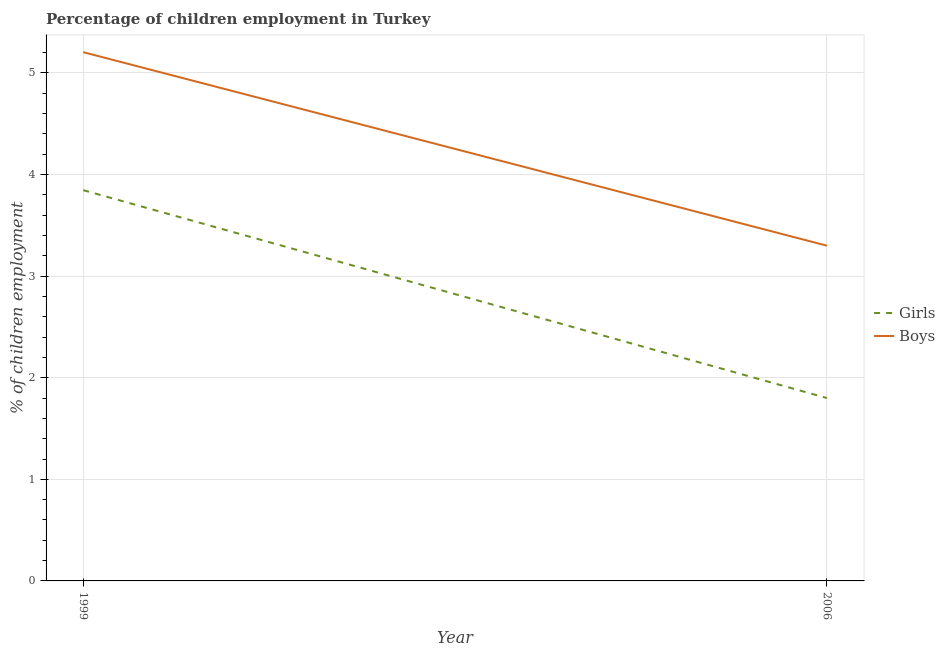How many different coloured lines are there?
Provide a succinct answer. 2. Does the line corresponding to percentage of employed boys intersect with the line corresponding to percentage of employed girls?
Provide a short and direct response. No. Is the number of lines equal to the number of legend labels?
Offer a very short reply. Yes. What is the percentage of employed boys in 1999?
Provide a succinct answer. 5.2. Across all years, what is the maximum percentage of employed boys?
Provide a succinct answer. 5.2. In which year was the percentage of employed girls minimum?
Provide a short and direct response. 2006. What is the total percentage of employed boys in the graph?
Keep it short and to the point. 8.5. What is the difference between the percentage of employed girls in 1999 and that in 2006?
Your response must be concise. 2.05. What is the difference between the percentage of employed girls in 2006 and the percentage of employed boys in 1999?
Your answer should be very brief. -3.4. What is the average percentage of employed girls per year?
Your answer should be very brief. 2.82. In the year 2006, what is the difference between the percentage of employed boys and percentage of employed girls?
Provide a succinct answer. 1.5. In how many years, is the percentage of employed boys greater than 1 %?
Your answer should be compact. 2. What is the ratio of the percentage of employed boys in 1999 to that in 2006?
Your response must be concise. 1.58. Is the percentage of employed girls in 1999 less than that in 2006?
Offer a very short reply. No. In how many years, is the percentage of employed girls greater than the average percentage of employed girls taken over all years?
Your answer should be compact. 1. Does the percentage of employed girls monotonically increase over the years?
Offer a terse response. No. Is the percentage of employed boys strictly greater than the percentage of employed girls over the years?
Make the answer very short. Yes. How many lines are there?
Your answer should be very brief. 2. Does the graph contain any zero values?
Provide a succinct answer. No. Does the graph contain grids?
Keep it short and to the point. Yes. Where does the legend appear in the graph?
Provide a succinct answer. Center right. How are the legend labels stacked?
Your answer should be compact. Vertical. What is the title of the graph?
Provide a succinct answer. Percentage of children employment in Turkey. What is the label or title of the Y-axis?
Give a very brief answer. % of children employment. What is the % of children employment in Girls in 1999?
Your answer should be compact. 3.85. What is the % of children employment in Boys in 1999?
Provide a short and direct response. 5.2. What is the % of children employment of Girls in 2006?
Keep it short and to the point. 1.8. What is the % of children employment in Boys in 2006?
Give a very brief answer. 3.3. Across all years, what is the maximum % of children employment in Girls?
Provide a short and direct response. 3.85. Across all years, what is the maximum % of children employment in Boys?
Ensure brevity in your answer.  5.2. Across all years, what is the minimum % of children employment of Girls?
Keep it short and to the point. 1.8. What is the total % of children employment in Girls in the graph?
Provide a succinct answer. 5.65. What is the total % of children employment in Boys in the graph?
Provide a succinct answer. 8.5. What is the difference between the % of children employment of Girls in 1999 and that in 2006?
Give a very brief answer. 2.05. What is the difference between the % of children employment in Boys in 1999 and that in 2006?
Provide a succinct answer. 1.9. What is the difference between the % of children employment in Girls in 1999 and the % of children employment in Boys in 2006?
Your answer should be compact. 0.55. What is the average % of children employment of Girls per year?
Your response must be concise. 2.82. What is the average % of children employment in Boys per year?
Make the answer very short. 4.25. In the year 1999, what is the difference between the % of children employment of Girls and % of children employment of Boys?
Give a very brief answer. -1.36. In the year 2006, what is the difference between the % of children employment in Girls and % of children employment in Boys?
Provide a succinct answer. -1.5. What is the ratio of the % of children employment in Girls in 1999 to that in 2006?
Provide a succinct answer. 2.14. What is the ratio of the % of children employment of Boys in 1999 to that in 2006?
Make the answer very short. 1.58. What is the difference between the highest and the second highest % of children employment in Girls?
Provide a short and direct response. 2.05. What is the difference between the highest and the second highest % of children employment of Boys?
Your answer should be very brief. 1.9. What is the difference between the highest and the lowest % of children employment in Girls?
Your answer should be compact. 2.05. What is the difference between the highest and the lowest % of children employment of Boys?
Provide a short and direct response. 1.9. 